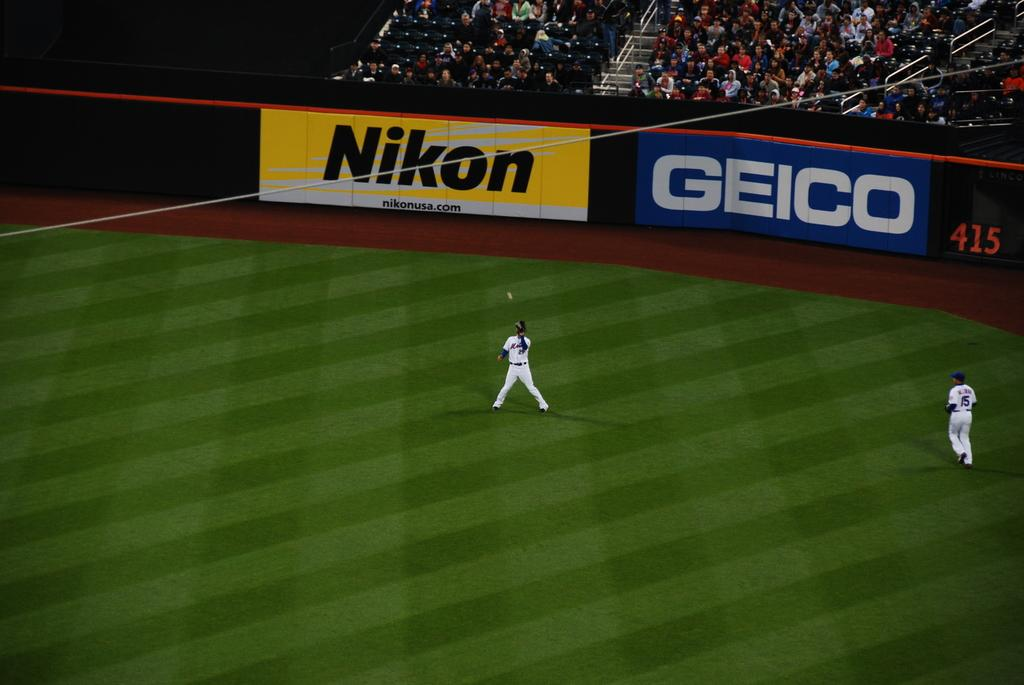<image>
Render a clear and concise summary of the photo. Baseball players on the stadium with an ad that says NIKON. 